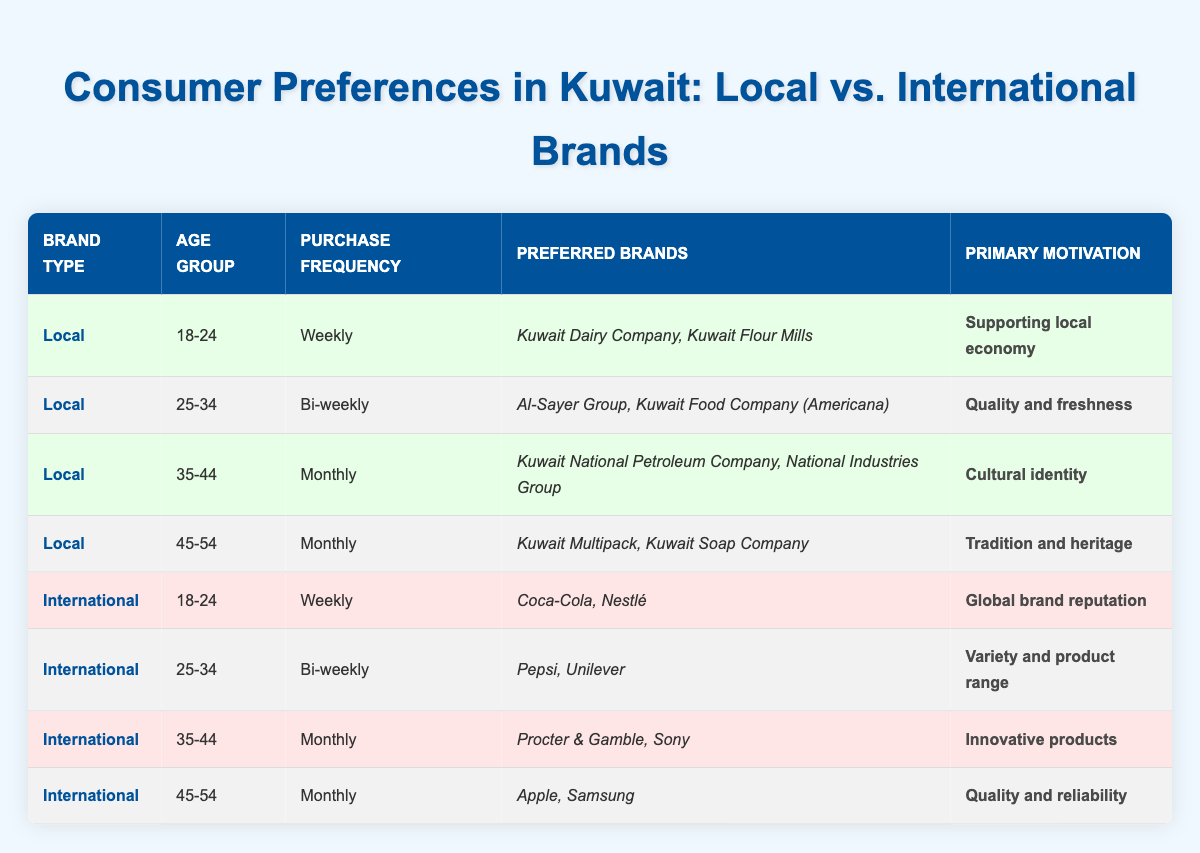What brands are preferred by the 18-24 age group for local options? According to the table, the preferred brands for the 18-24 age group under local options are Kuwait Dairy Company and Kuwait Flour Mills.
Answer: Kuwait Dairy Company, Kuwait Flour Mills Which age group prefers international brands with a purchase frequency of bi-weekly? The table indicates that the 25-34 age group prefers international brands with a purchase frequency of bi-weekly, as shown by the brands Pepsi and Unilever listed under that category.
Answer: 25-34 Is "Supporting local economy" the primary motivation for any local brand? Yes, the table specifies that "Supporting local economy" is the primary motivation for the local brands preferred by the 18-24 age group.
Answer: Yes How many different purchase frequencies are represented in the dataset? By reviewing the purchase frequency column, we can see the frequencies are Weekly, Bi-weekly, and Monthly, representing three different purchase frequencies in total.
Answer: 3 What is the primary motivation for the preferred brands of the 35-44 age group for local options? The table states that the primary motivation for the 35-44 age group regarding local brands is "Cultural identity."
Answer: Cultural identity Among all respondents, which brand type (local or international) has a higher preference for weekly purchases? The table shows that both local and international brands have a preference for weekly purchases, with local options for the 18-24 age group (two brands) and international options for the 18-24 age group (two brands) each with one instance, indicating equal preference.
Answer: Equal preference What is the average purchase frequency for local brands across all age groups in the table? Local brands appear with frequencies of Weekly, Bi-weekly, and Monthly. Converting these to numerical values (Weekly=1, Bi-weekly=2, Monthly=3), the average frequency is (1 + 2 + 3 + 3) / 4 = 2.25, indicating an average frequency of approximately between bi-weekly and monthly purchases.
Answer: 2.25 Does the table suggest that older age groups prefer local brands? Yes, the table shows that as the age groups increase, local brands are preferred for the 35-44 and 45-54 age groups. This trend indicates a preference for local options among older customers.
Answer: Yes What is the most common primary motivation for choosing international brands? The table lists various motivations for international brands, with "Quality and reliability" being the last primary motivation for the 45-54 age group and most frequently mentioned among the preferences. Therefore, it can be inferred that "Global brand reputation" has a notable presence across younger demographics.
Answer: Global brand reputation 